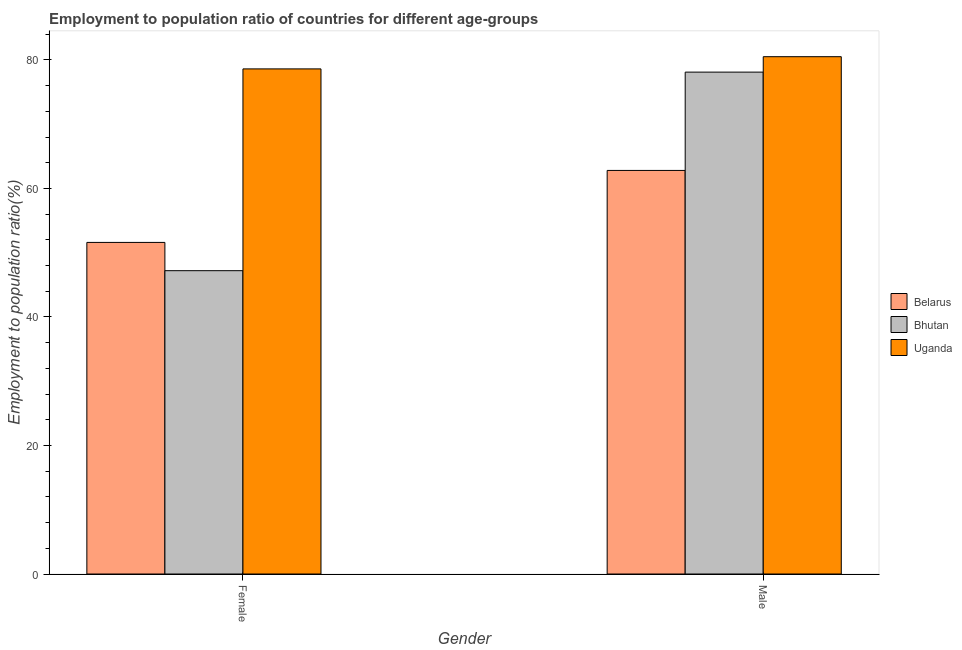What is the employment to population ratio(female) in Belarus?
Provide a succinct answer. 51.6. Across all countries, what is the maximum employment to population ratio(female)?
Your response must be concise. 78.6. Across all countries, what is the minimum employment to population ratio(female)?
Offer a terse response. 47.2. In which country was the employment to population ratio(female) maximum?
Your answer should be very brief. Uganda. In which country was the employment to population ratio(female) minimum?
Your response must be concise. Bhutan. What is the total employment to population ratio(male) in the graph?
Give a very brief answer. 221.4. What is the difference between the employment to population ratio(male) in Belarus and that in Uganda?
Provide a succinct answer. -17.7. What is the average employment to population ratio(female) per country?
Provide a succinct answer. 59.13. What is the difference between the employment to population ratio(male) and employment to population ratio(female) in Uganda?
Provide a short and direct response. 1.9. What is the ratio of the employment to population ratio(female) in Uganda to that in Belarus?
Provide a succinct answer. 1.52. In how many countries, is the employment to population ratio(male) greater than the average employment to population ratio(male) taken over all countries?
Offer a terse response. 2. What does the 3rd bar from the left in Female represents?
Give a very brief answer. Uganda. What does the 2nd bar from the right in Female represents?
Offer a very short reply. Bhutan. Are all the bars in the graph horizontal?
Keep it short and to the point. No. What is the difference between two consecutive major ticks on the Y-axis?
Provide a succinct answer. 20. Are the values on the major ticks of Y-axis written in scientific E-notation?
Make the answer very short. No. Does the graph contain any zero values?
Provide a short and direct response. No. Does the graph contain grids?
Give a very brief answer. No. Where does the legend appear in the graph?
Provide a short and direct response. Center right. How many legend labels are there?
Ensure brevity in your answer.  3. What is the title of the graph?
Your answer should be compact. Employment to population ratio of countries for different age-groups. What is the Employment to population ratio(%) in Belarus in Female?
Keep it short and to the point. 51.6. What is the Employment to population ratio(%) in Bhutan in Female?
Offer a very short reply. 47.2. What is the Employment to population ratio(%) of Uganda in Female?
Provide a succinct answer. 78.6. What is the Employment to population ratio(%) in Belarus in Male?
Make the answer very short. 62.8. What is the Employment to population ratio(%) in Bhutan in Male?
Your answer should be compact. 78.1. What is the Employment to population ratio(%) in Uganda in Male?
Offer a terse response. 80.5. Across all Gender, what is the maximum Employment to population ratio(%) in Belarus?
Offer a terse response. 62.8. Across all Gender, what is the maximum Employment to population ratio(%) in Bhutan?
Make the answer very short. 78.1. Across all Gender, what is the maximum Employment to population ratio(%) of Uganda?
Keep it short and to the point. 80.5. Across all Gender, what is the minimum Employment to population ratio(%) in Belarus?
Provide a short and direct response. 51.6. Across all Gender, what is the minimum Employment to population ratio(%) in Bhutan?
Provide a succinct answer. 47.2. Across all Gender, what is the minimum Employment to population ratio(%) in Uganda?
Give a very brief answer. 78.6. What is the total Employment to population ratio(%) of Belarus in the graph?
Provide a succinct answer. 114.4. What is the total Employment to population ratio(%) in Bhutan in the graph?
Provide a succinct answer. 125.3. What is the total Employment to population ratio(%) in Uganda in the graph?
Provide a succinct answer. 159.1. What is the difference between the Employment to population ratio(%) in Belarus in Female and that in Male?
Give a very brief answer. -11.2. What is the difference between the Employment to population ratio(%) of Bhutan in Female and that in Male?
Keep it short and to the point. -30.9. What is the difference between the Employment to population ratio(%) in Uganda in Female and that in Male?
Your answer should be very brief. -1.9. What is the difference between the Employment to population ratio(%) of Belarus in Female and the Employment to population ratio(%) of Bhutan in Male?
Ensure brevity in your answer.  -26.5. What is the difference between the Employment to population ratio(%) of Belarus in Female and the Employment to population ratio(%) of Uganda in Male?
Your answer should be compact. -28.9. What is the difference between the Employment to population ratio(%) of Bhutan in Female and the Employment to population ratio(%) of Uganda in Male?
Your answer should be very brief. -33.3. What is the average Employment to population ratio(%) of Belarus per Gender?
Your answer should be compact. 57.2. What is the average Employment to population ratio(%) of Bhutan per Gender?
Provide a short and direct response. 62.65. What is the average Employment to population ratio(%) in Uganda per Gender?
Your answer should be compact. 79.55. What is the difference between the Employment to population ratio(%) of Belarus and Employment to population ratio(%) of Bhutan in Female?
Provide a short and direct response. 4.4. What is the difference between the Employment to population ratio(%) in Bhutan and Employment to population ratio(%) in Uganda in Female?
Your answer should be compact. -31.4. What is the difference between the Employment to population ratio(%) of Belarus and Employment to population ratio(%) of Bhutan in Male?
Offer a very short reply. -15.3. What is the difference between the Employment to population ratio(%) of Belarus and Employment to population ratio(%) of Uganda in Male?
Provide a short and direct response. -17.7. What is the ratio of the Employment to population ratio(%) in Belarus in Female to that in Male?
Provide a succinct answer. 0.82. What is the ratio of the Employment to population ratio(%) in Bhutan in Female to that in Male?
Ensure brevity in your answer.  0.6. What is the ratio of the Employment to population ratio(%) of Uganda in Female to that in Male?
Your response must be concise. 0.98. What is the difference between the highest and the second highest Employment to population ratio(%) in Belarus?
Make the answer very short. 11.2. What is the difference between the highest and the second highest Employment to population ratio(%) of Bhutan?
Your answer should be very brief. 30.9. What is the difference between the highest and the second highest Employment to population ratio(%) in Uganda?
Make the answer very short. 1.9. What is the difference between the highest and the lowest Employment to population ratio(%) in Bhutan?
Give a very brief answer. 30.9. 